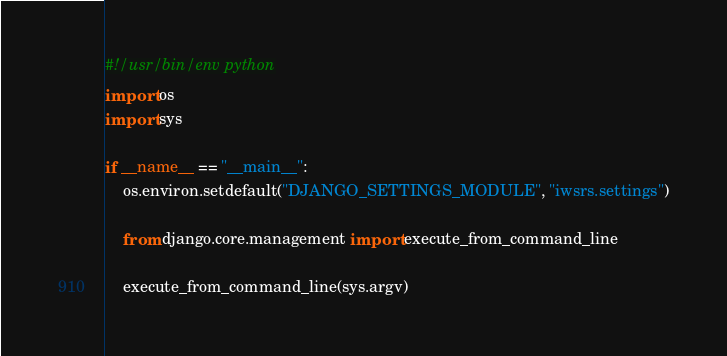Convert code to text. <code><loc_0><loc_0><loc_500><loc_500><_Python_>#!/usr/bin/env python
import os
import sys

if __name__ == "__main__":
    os.environ.setdefault("DJANGO_SETTINGS_MODULE", "iwsrs.settings")

    from django.core.management import execute_from_command_line

    execute_from_command_line(sys.argv)
</code> 